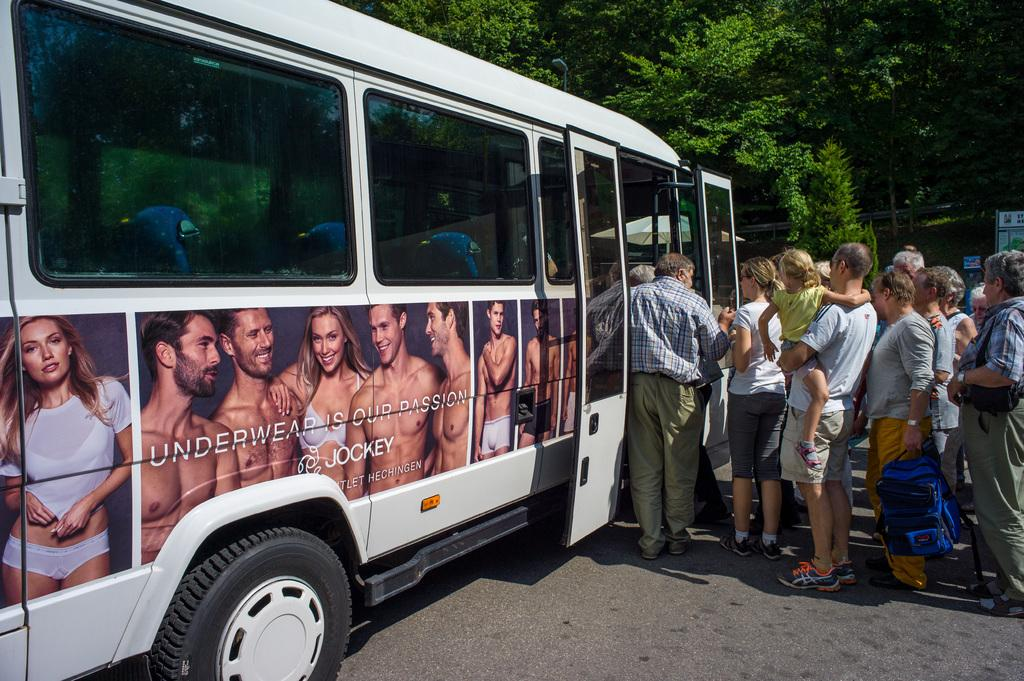<image>
Present a compact description of the photo's key features. People line up to board a bus which has Underwear is Our Passion written on the side 